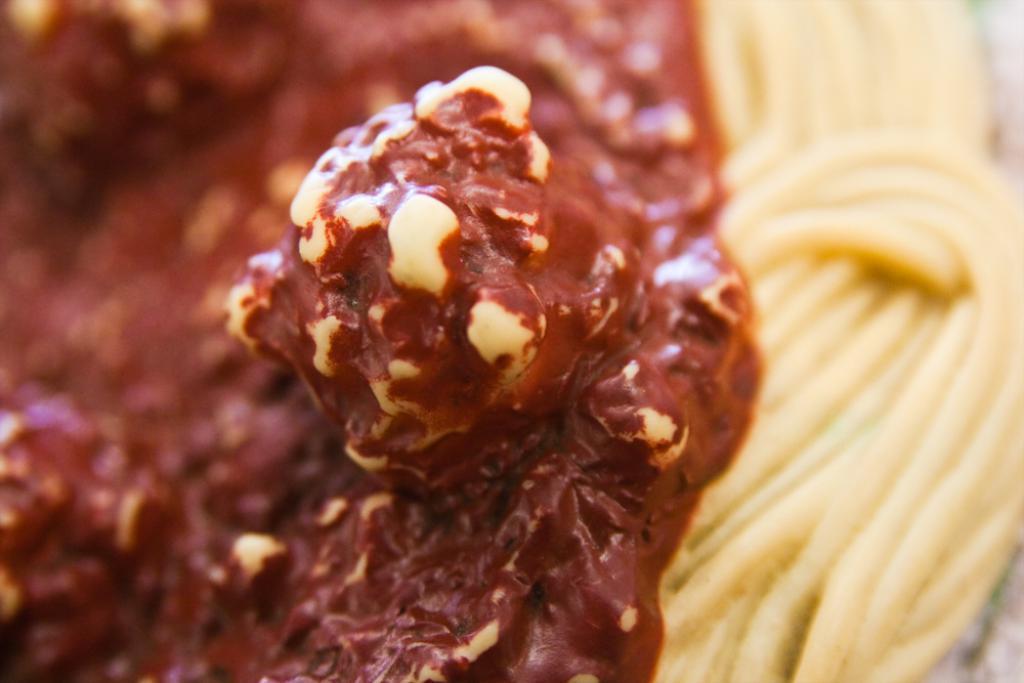Describe this image in one or two sentences. This image consists of chocolate cream along with noodles. And there are nuts in the caramel. 